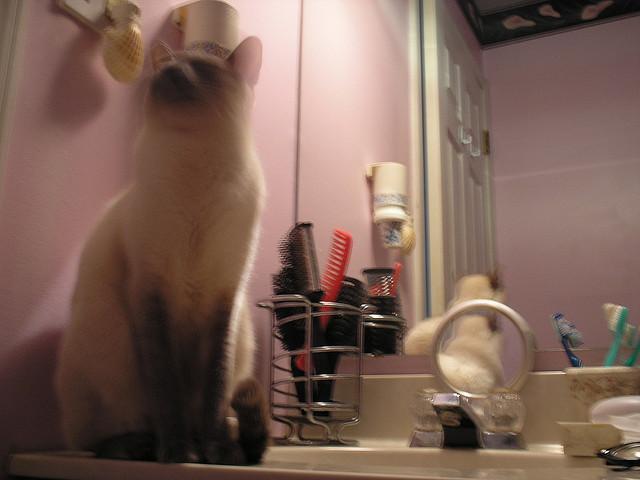What is the red item inside the holder?
From the following set of four choices, select the accurate answer to respond to the question.
Options: Comb, floss, razor, toothbrush. Comb. 